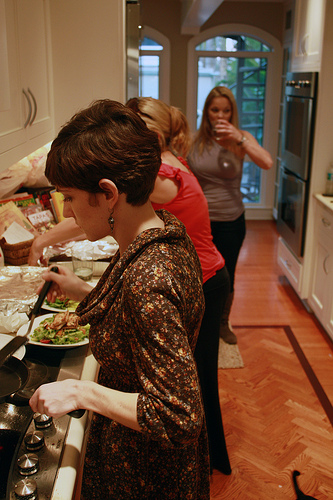Please provide the bounding box coordinate of the region this sentence describes: a white plate. [0.2, 0.62, 0.34, 0.7]. This box likely includes a white plate, possibly seen on a counter or table within the kitchen. 